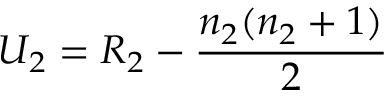<formula> <loc_0><loc_0><loc_500><loc_500>U _ { 2 } = R _ { 2 } - { \frac { n _ { 2 } ( n _ { 2 } + 1 ) } { 2 } } \,</formula> 